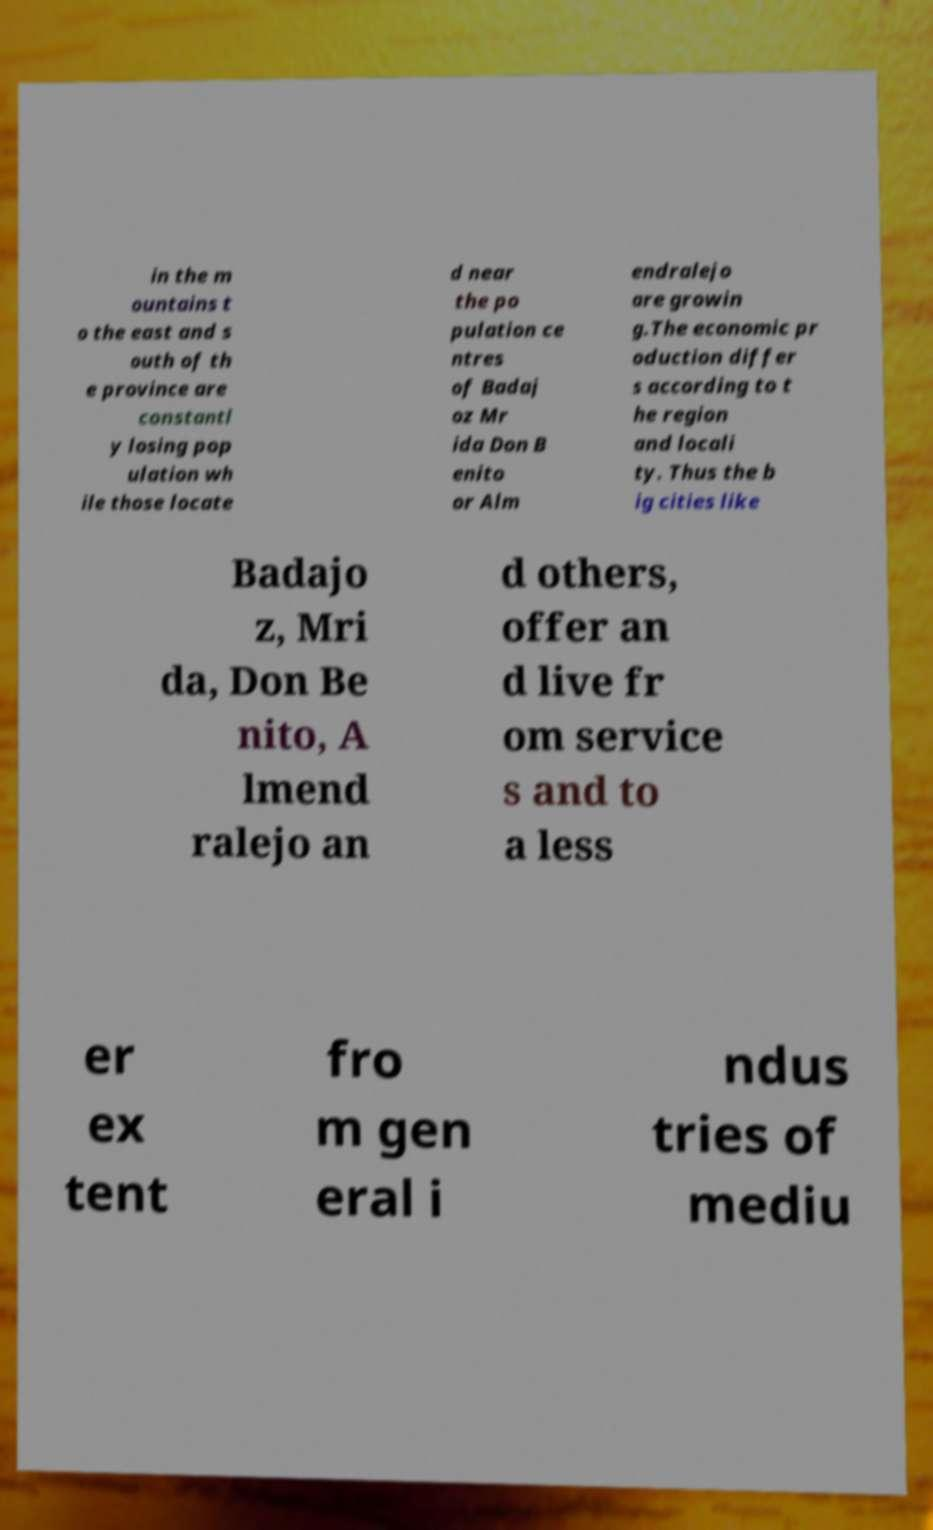Could you assist in decoding the text presented in this image and type it out clearly? in the m ountains t o the east and s outh of th e province are constantl y losing pop ulation wh ile those locate d near the po pulation ce ntres of Badaj oz Mr ida Don B enito or Alm endralejo are growin g.The economic pr oduction differ s according to t he region and locali ty. Thus the b ig cities like Badajo z, Mri da, Don Be nito, A lmend ralejo an d others, offer an d live fr om service s and to a less er ex tent fro m gen eral i ndus tries of mediu 